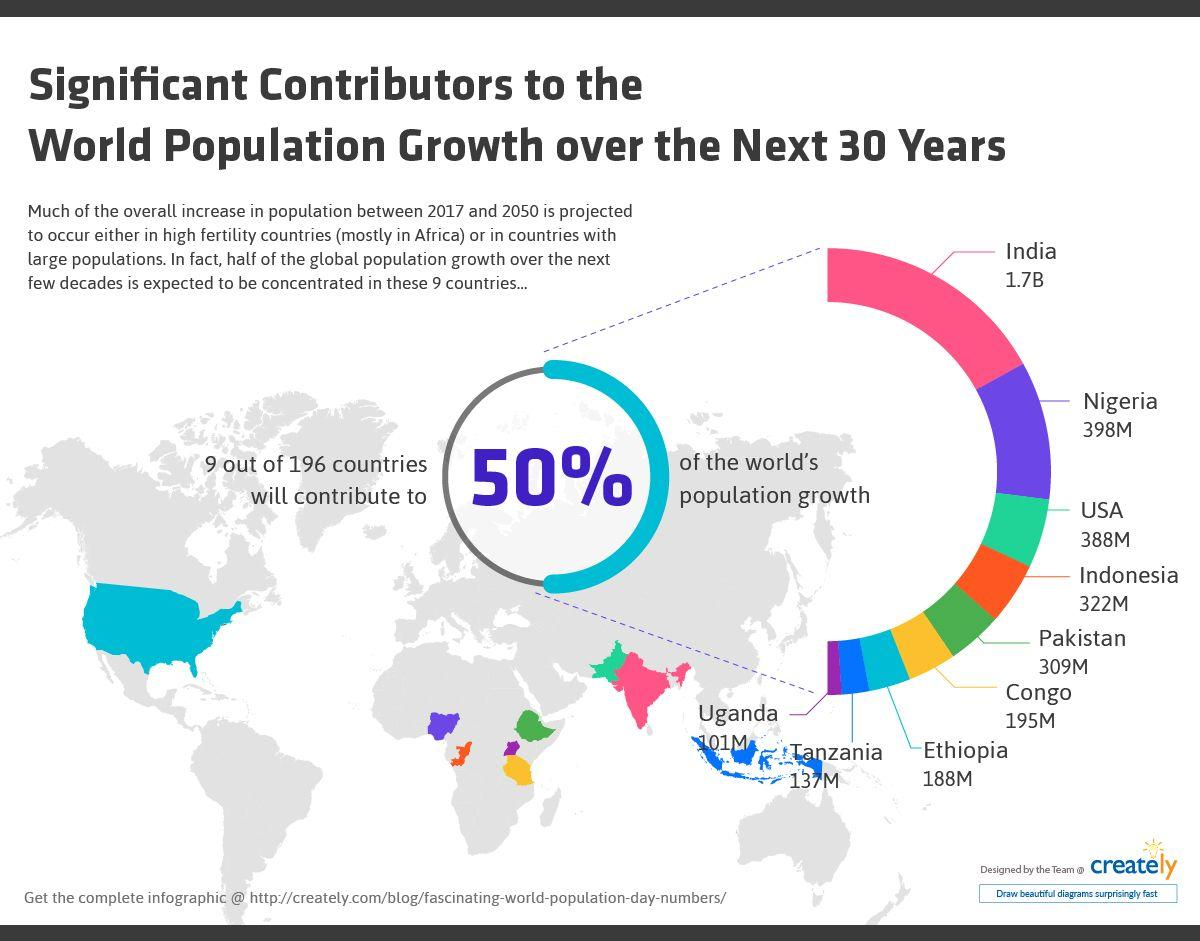Draw attention to some important aspects in this diagram. In the past, India was often represented by the color pink. However, this has changed and India is now typically represented by the color orange. Orange was formerly used to represent Indonesia. The combined population of Pakistan and Indonesia over the next 30 years is projected to be 631 million. The population of Nigeria and the USA, taken together, is projected to be approximately 786 million over the next 30 years. The population of Ethiopia and Congo taken together over the next 30 years is projected to be 383 million. 